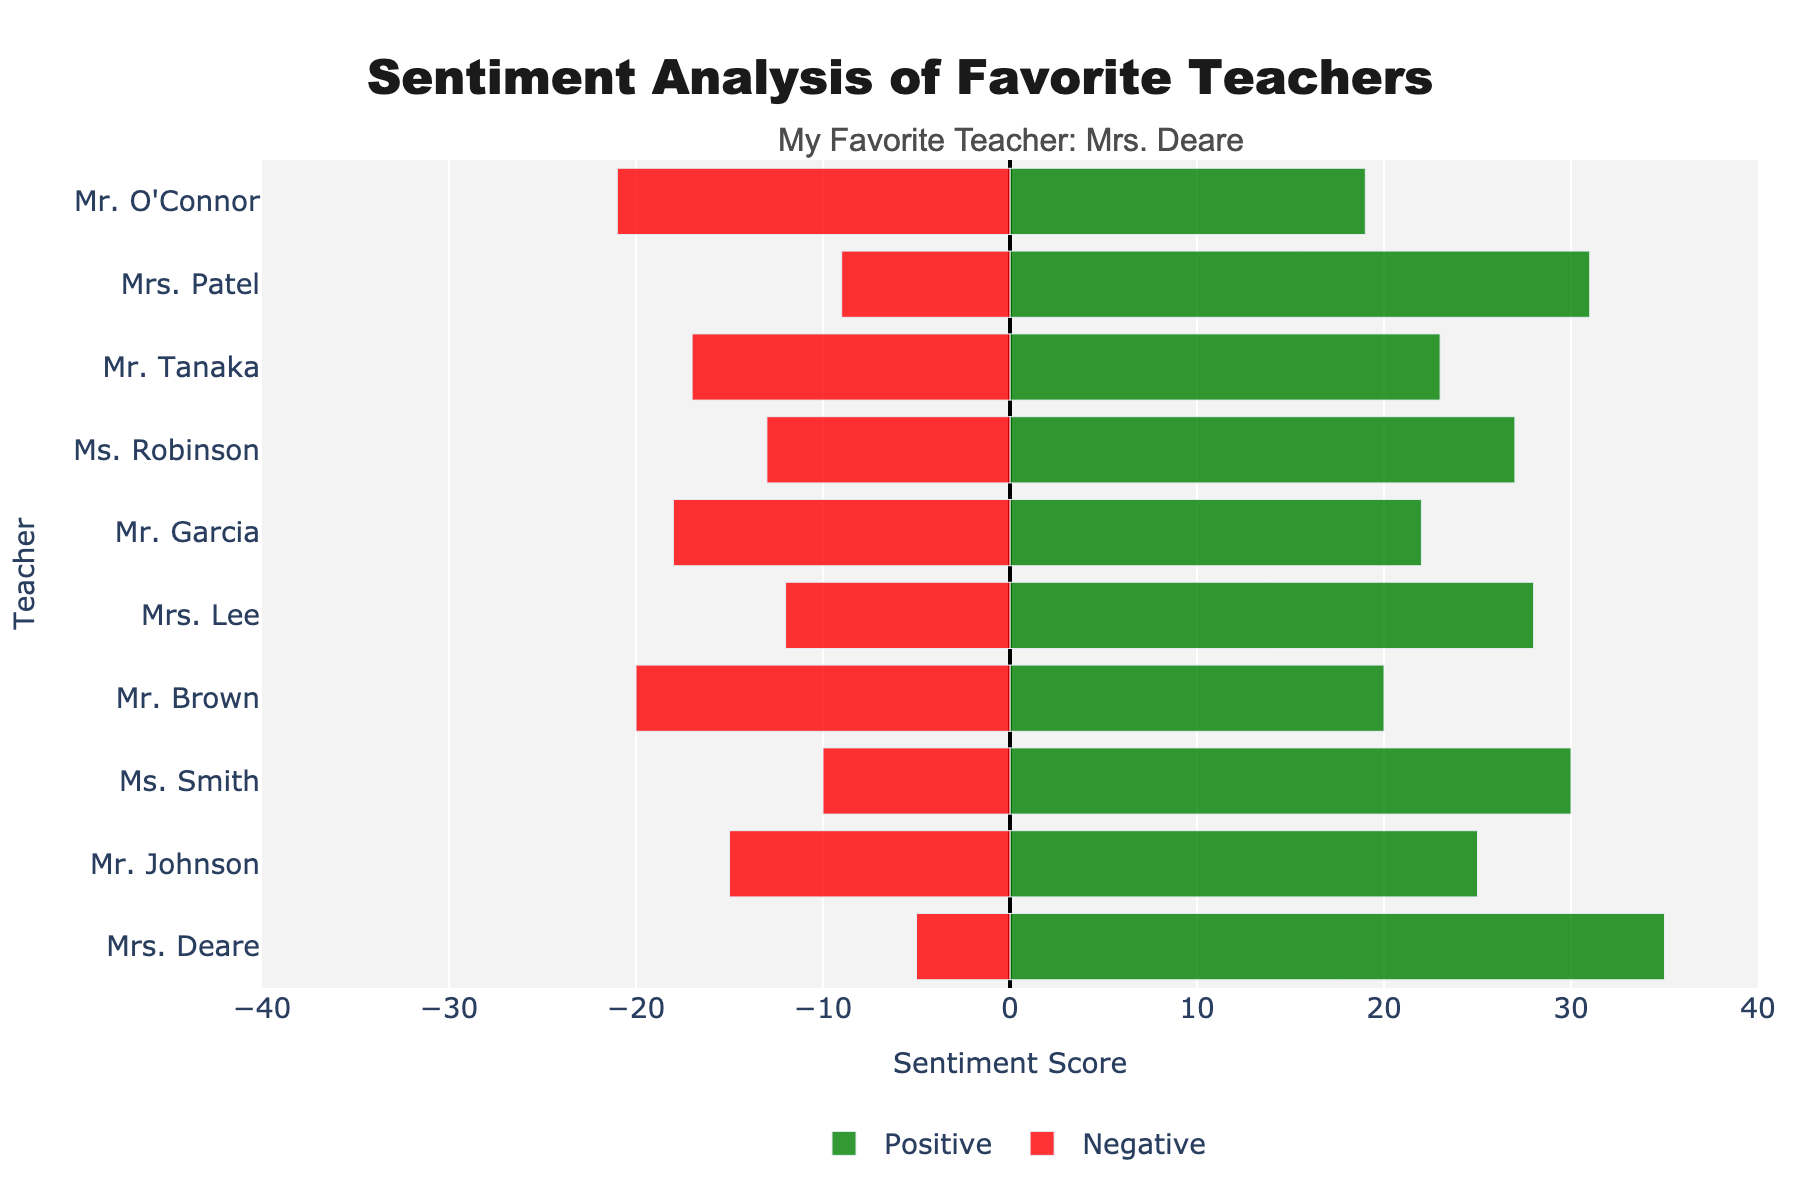What's the total number of positive responses for Mrs. Deare and Mrs. Patel combined? Add the positive responses for Mrs. Deare (35) and Mrs. Patel (31). So, the total is 35 + 31 = 66.
Answer: 66 Who received more positive responses, Mr. Johnson or Ms. Robinson? Compare the positive responses: Mr. Johnson has 25 and Ms. Robinson has 27. Ms. Robinson received more positive responses.
Answer: Ms. Robinson Which teacher has the largest difference between positive and negative responses? Calculate the differences for each teacher and find the largest: Mrs. Deare (35-5=30), Mr. Johnson (25-15=10), Ms. Smith (30-10=20), Mr. Brown (20-20=0), Mrs. Lee (28-12=16), Mr. Garcia (22-18=4), Ms. Robinson (27-13=14), Mr. Tanaka (23-17=6), Mrs. Patel (31-9=22), Mr. O'Connor (19-21=-2). Mrs. Deare has the largest difference of 30.
Answer: Mrs. Deare How many teachers have more negative responses than positive responses? Examine the bar chart: Mr. Brown (20 negative, 20 positive), Mr. Garcia (18 negative, 22 positive), Mr. Tanaka (17 negative, 23 positive), Mr. O'Connor (21 negative, 19 positive). Only Mr. O'Connor has more negative responses (21) than positive responses (19).
Answer: 1 Which teacher has the smallest total number of responses? Calculate the total responses (positive + negative) for each teacher: Mrs. Deare (40), Mr. Johnson (40), Ms. Smith (40), Mr. Brown (40), Mrs. Lee (40), Mr. Garcia (40), Ms. Robinson (40), Mr. Tanaka (40), Mrs. Patel (40), Mr. O'Connor (40). All teachers have equal total responses, so technically no teacher has the smallest total. An example with smaller totals is not present.
Answer: All are equal Which teacher has the longest green bar? The longest green (positive) bar: Mrs. Deare with 35 positive responses is the longest green bar in the visualization.
Answer: Mrs. Deare Who received the fewest positive responses? Identify the shortest green bar: Mr. O'Connor received 19 positive responses, which is the fewest.
Answer: Mr. O'Connor What is the average number of positive responses across all teachers? Sum all positive responses: 35 + 25 + 30 + 20 + 28 + 22 + 27 + 23 + 31 + 19 = 260. Divide by the number of teachers (10): 260 / 10 = 26.
Answer: 26 Compare the negative responses between Mrs. Lee and Mr. Tanaka. Who received more? Mrs. Lee has 12 negative responses and Mr. Tanaka has 17. So, Mr. Tanaka received more negative responses.
Answer: Mr. Tanaka 